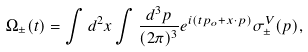Convert formula to latex. <formula><loc_0><loc_0><loc_500><loc_500>\Omega _ { \pm } ( t ) = \int d ^ { 2 } x \int \frac { d ^ { 3 } p } { ( 2 \pi ) ^ { 3 } } e ^ { i ( t p _ { o } + x \cdot p ) } \sigma _ { \pm } ^ { V } ( p ) ,</formula> 